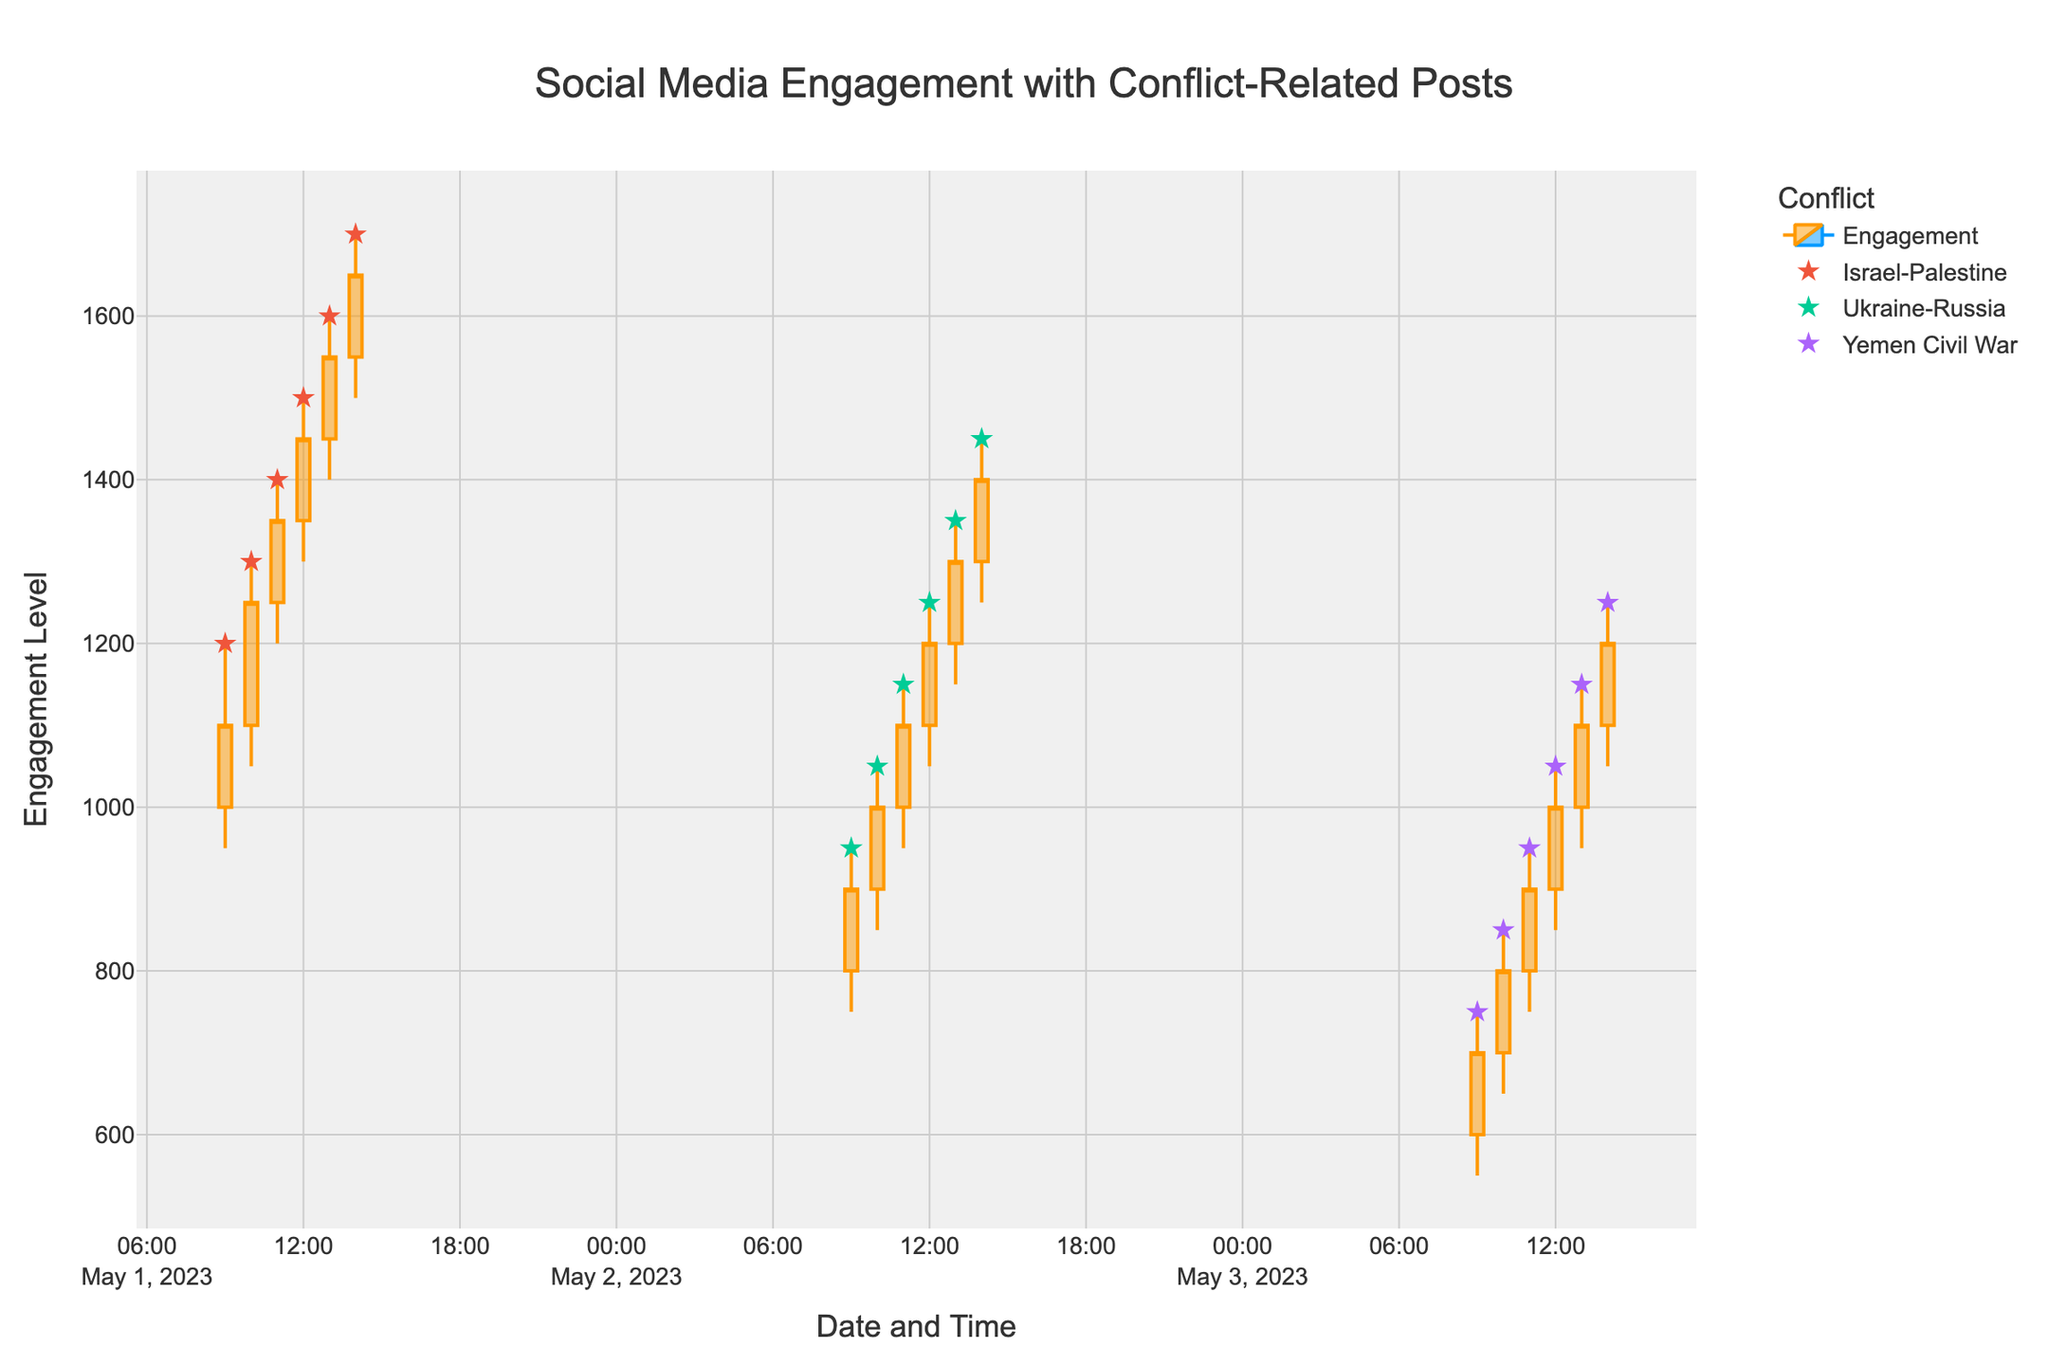What is the title of the figure? The title of the figure is displayed at the top center. It reads "Social Media Engagement with Conflict-Related Posts".
Answer: Social Media Engagement with Conflict-Related Posts What does the x-axis represent? The x-axis represents "Date and Time", indicating the hourly intervals at which social media engagement was measured.
Answer: Date and Time Which conflict showed the highest engagement level in a single interval? By looking at the highest points on the candlestick chart, the Israel-Palestine conflict on 2023-05-01 at 14:00 had the highest engagement level with a 'High' value of 1700.
Answer: Israel-Palestine What color represents increasing engagement levels? The increasing engagement levels are indicated by lines colored in orange.
Answer: Orange Compare the opening engagement levels of the Ukraine-Russia conflict on May 2nd at 09:00 and 10:00. Which one is higher? The opening engagement level at 10:00 is higher (900) compared to that at 09:00 (800).
Answer: 10:00 On which date did the Yemen Civil War posts have the lowest engagement level? The Yemen Civil War posts had the lowest engagement on 2023-05-03 at 09:00 with a 'Low' value of 550.
Answer: 2023-05-03 What is the average closing engagement level for the Israel-Palestine conflict on May 1st? The closing engagement levels for Israel-Palestine on May 1st are 1100, 1250, 1350, 1450, and 1550. Their sum is 6700, and the average is 6700 / 5 = 1340.
Answer: 1340 How many conflicts are represented in the chart? Each conflict is marked by different patterns of engagement, and there are a total of three unique conflicts shown in the chart.
Answer: 3 Between Yemen Civil War and Ukraine-Russia, which had a more stable engagement pattern based on the hourly changes? Stability can be assessed by looking at less fluctuation in highs and lows over time. The Yemen Civil War had more consistently spaced highs and lows compared to the larger fluctuations seen with Ukraine-Russia.
Answer: Yemen Civil War 